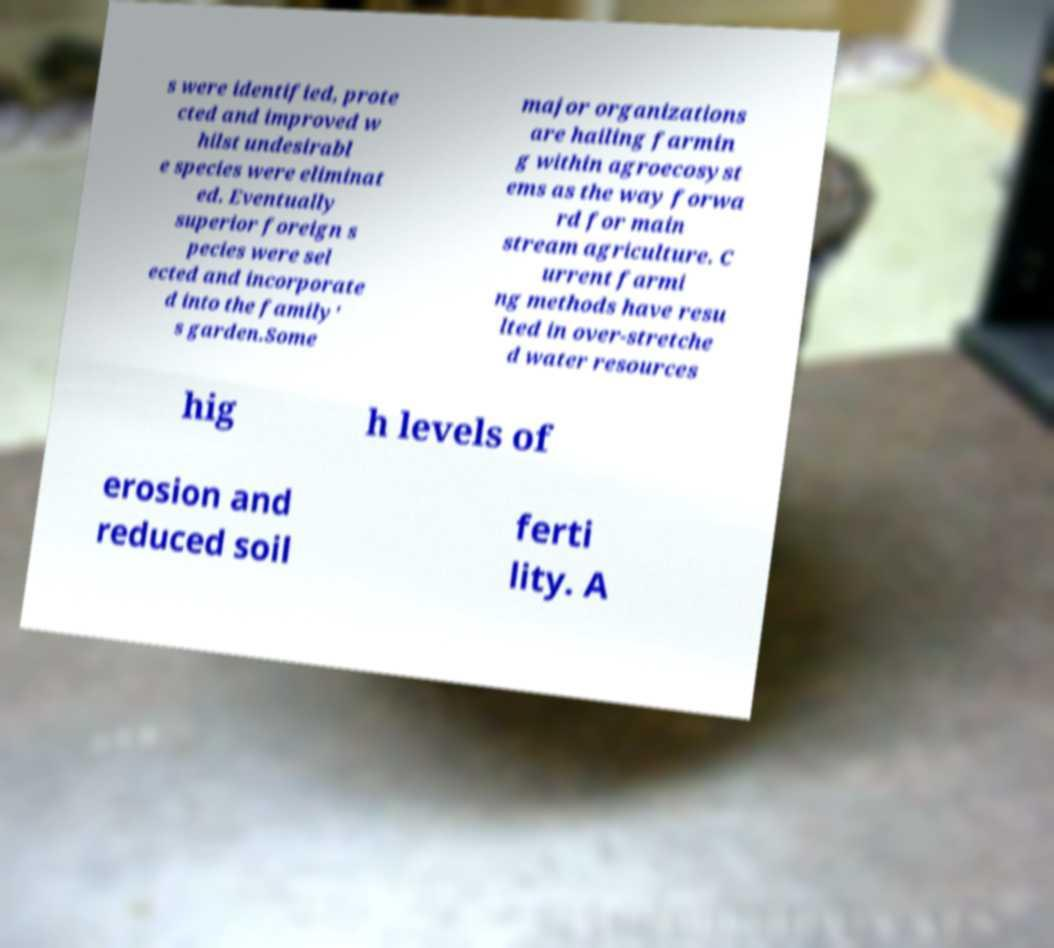There's text embedded in this image that I need extracted. Can you transcribe it verbatim? s were identified, prote cted and improved w hilst undesirabl e species were eliminat ed. Eventually superior foreign s pecies were sel ected and incorporate d into the family' s garden.Some major organizations are hailing farmin g within agroecosyst ems as the way forwa rd for main stream agriculture. C urrent farmi ng methods have resu lted in over-stretche d water resources hig h levels of erosion and reduced soil ferti lity. A 